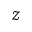Convert formula to latex. <formula><loc_0><loc_0><loc_500><loc_500>\mathcal { Z }</formula> 